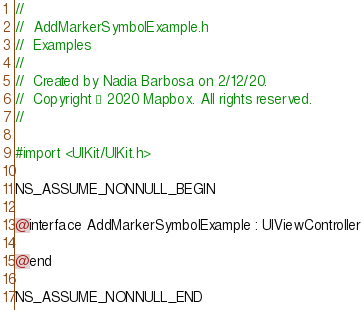<code> <loc_0><loc_0><loc_500><loc_500><_C_>//
//  AddMarkerSymbolExample.h
//  Examples
//
//  Created by Nadia Barbosa on 2/12/20.
//  Copyright © 2020 Mapbox. All rights reserved.
//

#import <UIKit/UIKit.h>

NS_ASSUME_NONNULL_BEGIN

@interface AddMarkerSymbolExample : UIViewController

@end

NS_ASSUME_NONNULL_END
</code> 